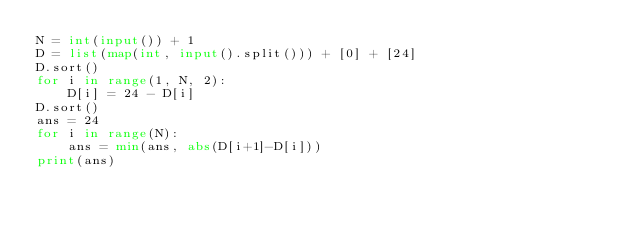<code> <loc_0><loc_0><loc_500><loc_500><_Python_>N = int(input()) + 1
D = list(map(int, input().split())) + [0] + [24]
D.sort()
for i in range(1, N, 2):
    D[i] = 24 - D[i]
D.sort()
ans = 24
for i in range(N):
    ans = min(ans, abs(D[i+1]-D[i]))
print(ans)
</code> 